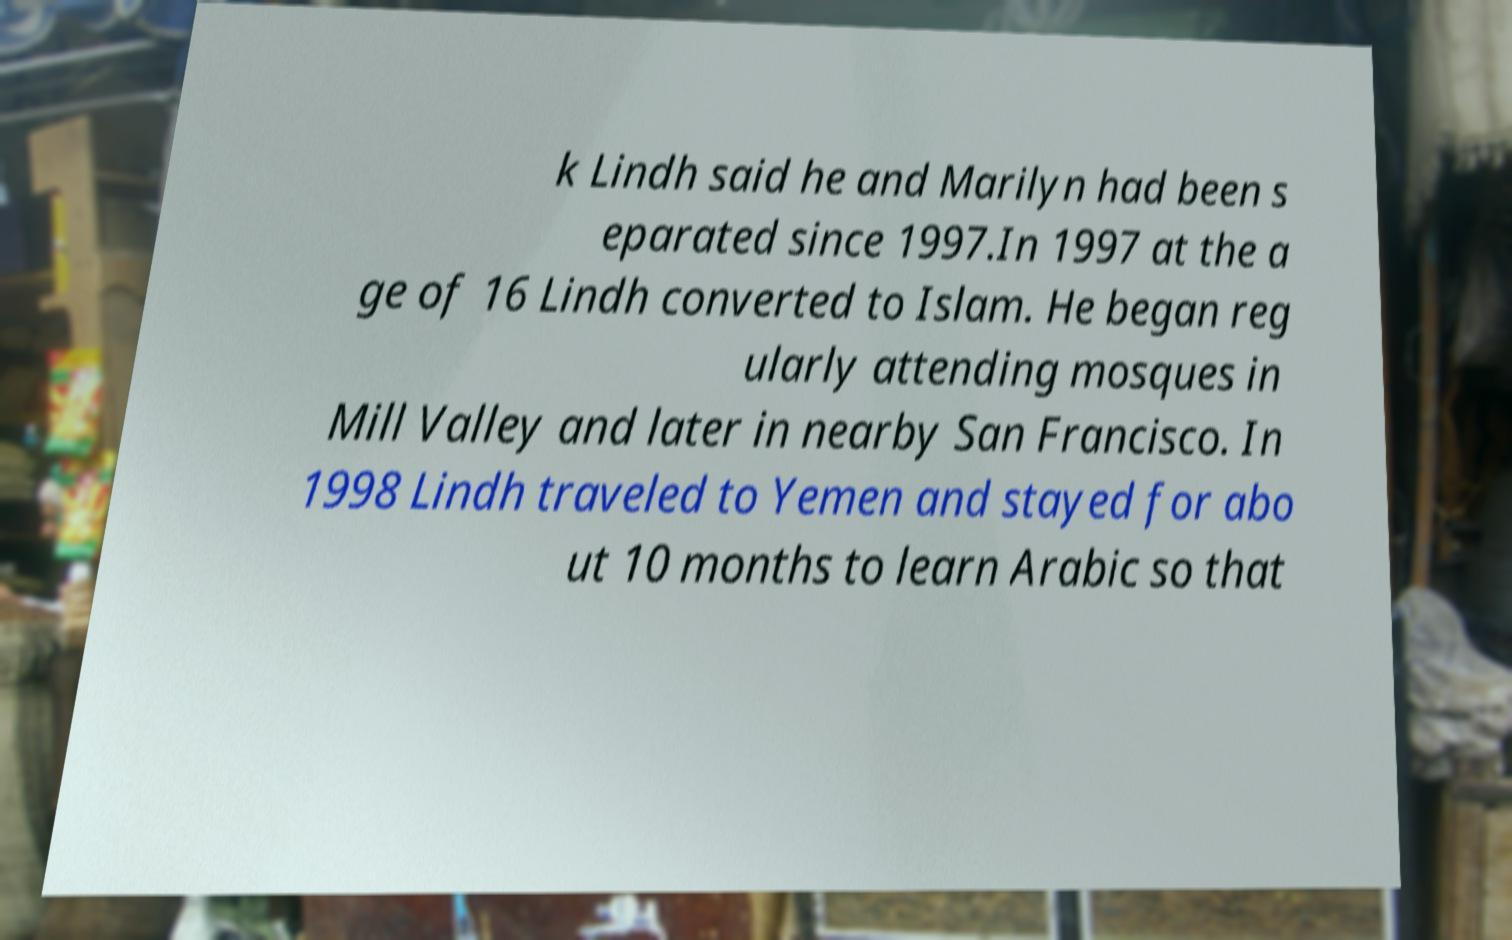I need the written content from this picture converted into text. Can you do that? k Lindh said he and Marilyn had been s eparated since 1997.In 1997 at the a ge of 16 Lindh converted to Islam. He began reg ularly attending mosques in Mill Valley and later in nearby San Francisco. In 1998 Lindh traveled to Yemen and stayed for abo ut 10 months to learn Arabic so that 